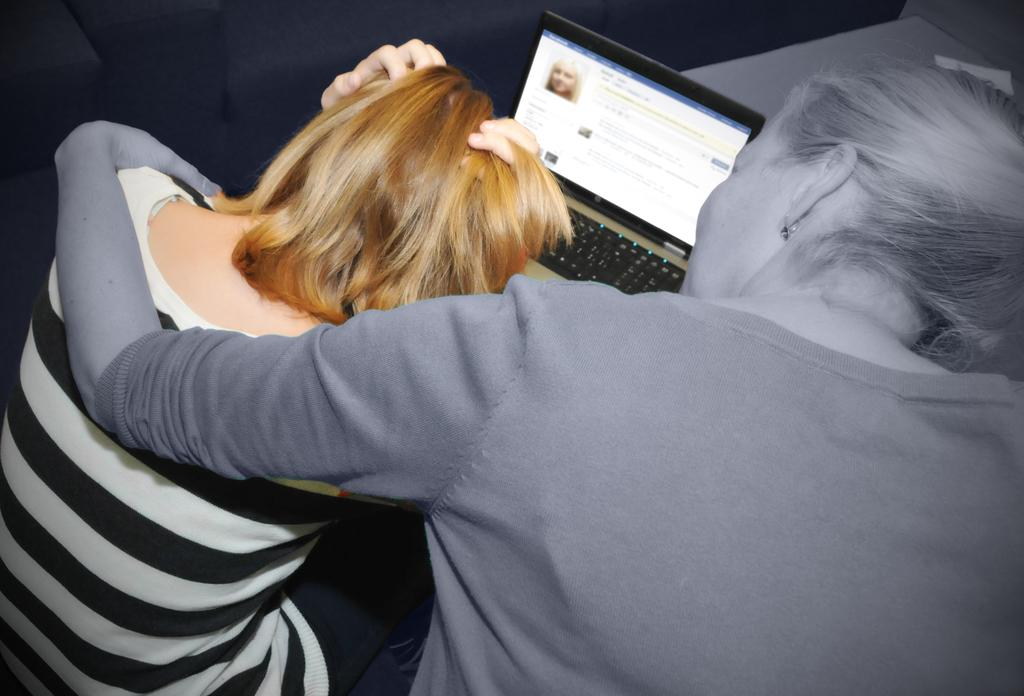How many people are sitting in the image? There are two women sitting in the image. What electronic device can be seen in the image? There is a laptop visible in the image. What is displayed on the laptop's screen? The laptop's screen displays a person's face. What type of quartz can be seen on the table in the image? There is no quartz present in the image. How many potatoes are visible in the image? There are no potatoes present in the image. 